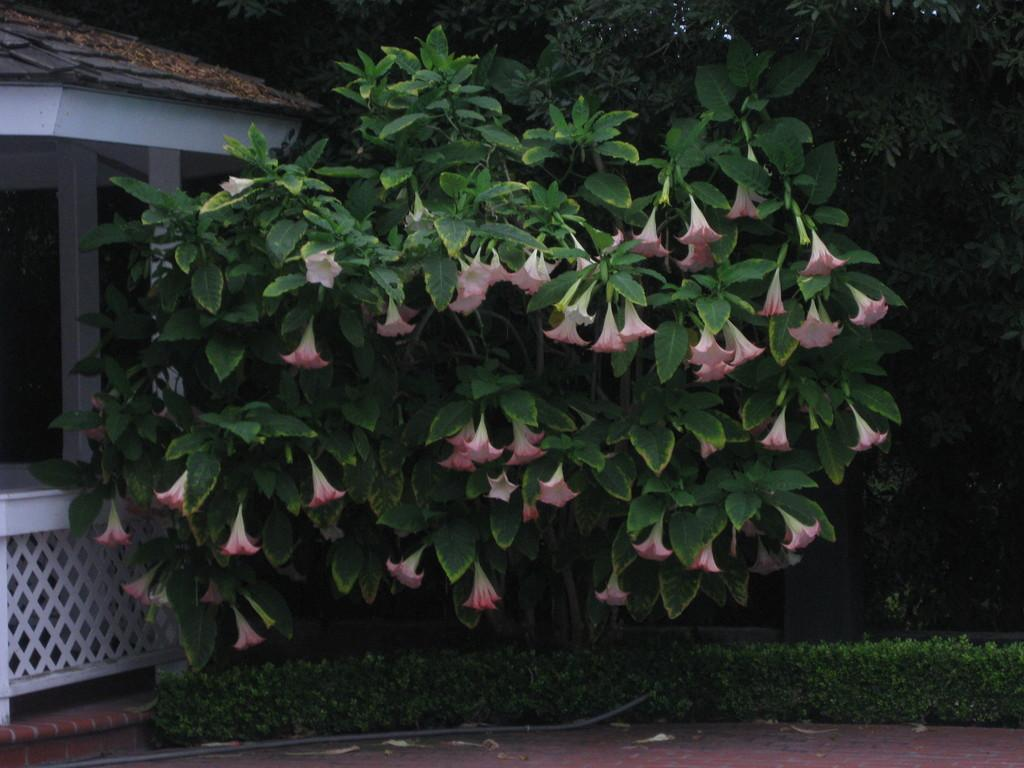What type of vegetation is in the foreground of the image? There are flowers on a plant in the foreground of the image. What can be seen at the bottom of the image? There are plants at the bottom of the image. What structure is located on the left side of the image? There is a shed on the left side of the image. What type of natural scenery is visible in the background of the image? There are trees in the background of the image. Who is the representative of the coal industry in the image? There is no representative of the coal industry present in the image. What type of parent is visible in the image? There is no parent visible in the image; it features plants, flowers, a shed, and trees. 